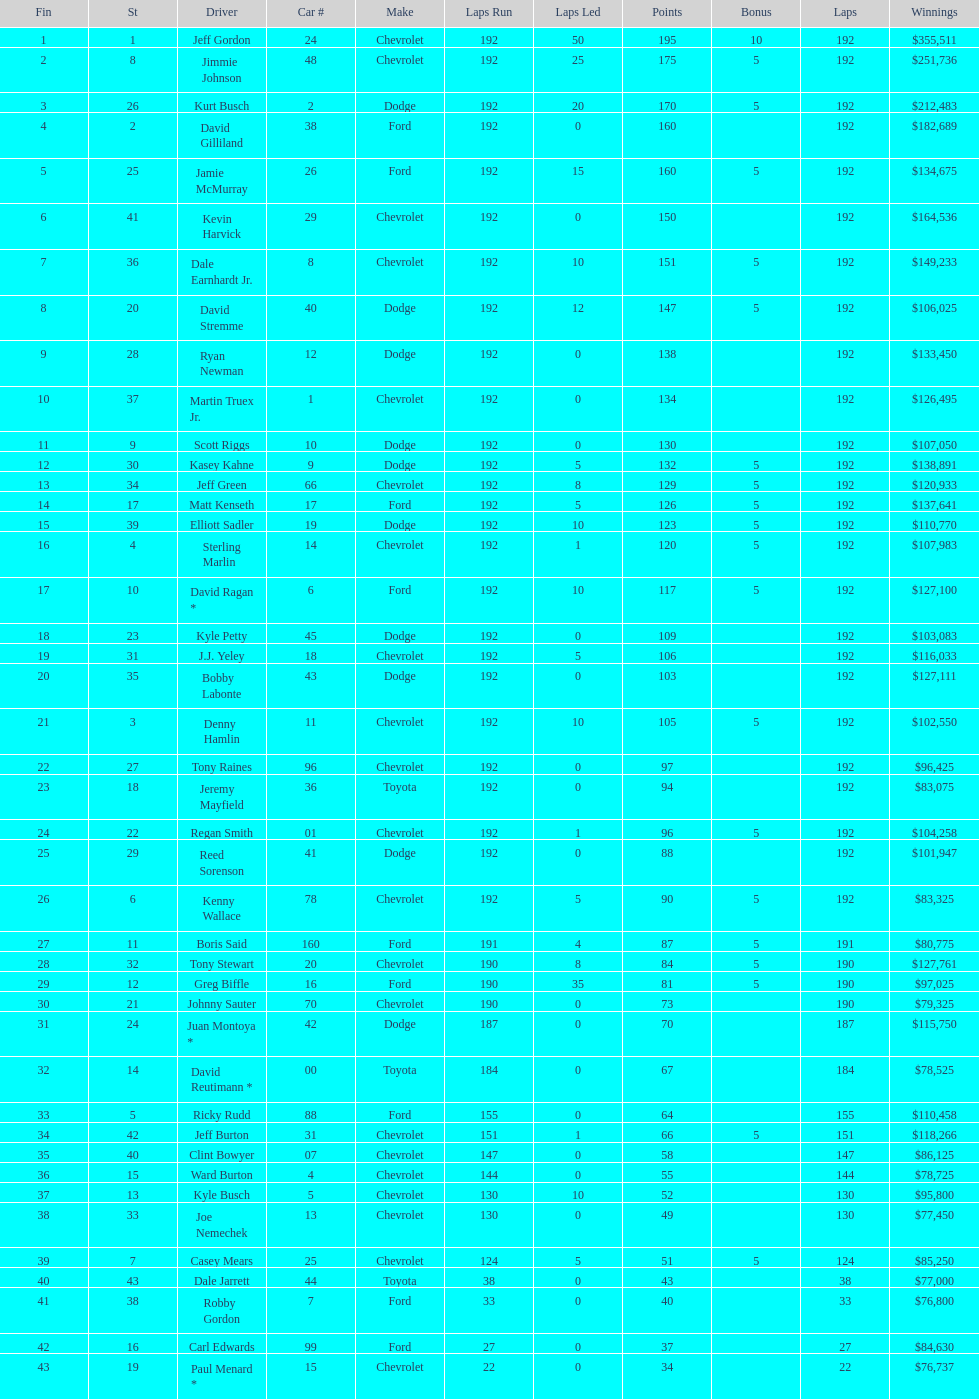What driver earned the least amount of winnings? Paul Menard *. 